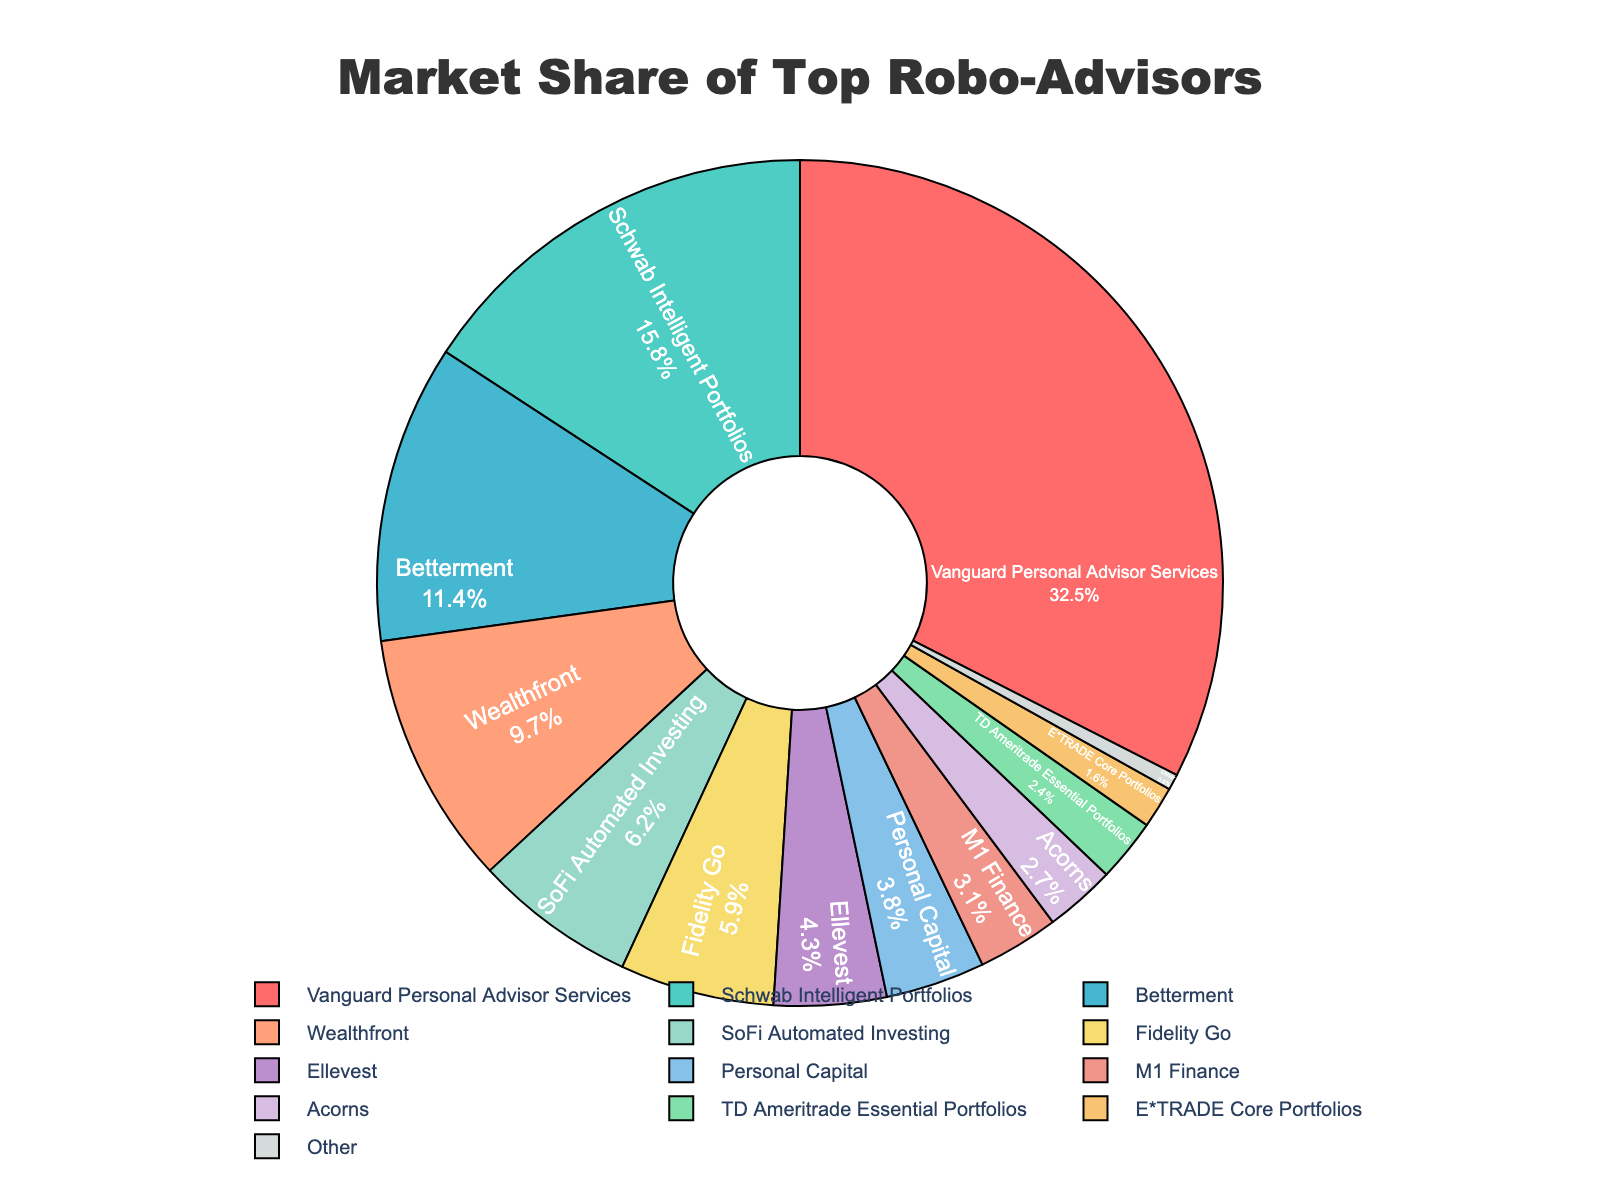Which company has the largest market share? The figure shows several companies and their corresponding market shares. The largest segment in the pie chart is colored and labeled with Vanguard Personal Advisor Services at 32.5%.
Answer: Vanguard Personal Advisor Services What's the combined market share of Schwab Intelligent Portfolios and Betterment? Schwab Intelligent Portfolios has a market share of 15.8%, and Betterment has 11.4%. Adding these two values gives 15.8 + 11.4 = 27.2%.
Answer: 27.2% Which company has a market share less than 5% but more than 3%? By looking at the segments, Fidelity Go (5.9%) is slightly more than 5%, but three companies lie between 3% and 5%: Ellevest (4.3%), Personal Capital (3.8%), and M1 Finance (3.1%).
Answer: Ellevest, Personal Capital, M1 Finance What is the market share difference between Wealthfront and SoFi Automated Investing? Wealthfront has a market share of 9.7% and SoFi Automated Investing has 6.2%. The difference is calculated as 9.7 - 6.2 = 3.5%.
Answer: 3.5% Which company has the smallest market share and what is it? The figure indicates multiple companies, but the smallest segment is denoted as "Other" with a market share of 0.6%.
Answer: Other, 0.6% How does the market share of Acorns compare to that of TD Ameritrade Essential Portfolios? The market share for Acorns is 2.7%, while TD Ameritrade Essential Portfolios have a market share of 2.4%. Acorns has a slightly higher market share than TD Ameritrade Essential Portfolios.
Answer: Acorns is higher What is the total market share of the companies that have a market share less than 10%? The companies with less than 10% market share are Betterment (11.4% is excluded), Wealthfront (9.7%), SoFi Automated Investing (6.2%), Fidelity Go (5.9%), Ellevest (4.3%), Personal Capital (3.8%), M1 Finance (3.1%), Acorns (2.7%), TD Ameritrade Essential Portfolios (2.4%), E*TRADE Core Portfolios (1.6%), and Other (0.6%). Summing these up: 9.7 + 6.2 + 5.9 + 4.3 + 3.8 + 3.1 + 2.7 + 2.4 + 1.6 + 0.6 = 40.3%.
Answer: 40.3% What percentage of the market is captured by companies that are not in the top 4 by market share? The top 4 companies by market share are Vanguard Personal Advisor Services (32.5%), Schwab Intelligent Portfolios (15.8%), Betterment (11.4%), and Wealthfront (9.7%). Adding these gives 32.5 + 15.8 + 11.4 + 9.7 = 69.4%. The rest of the companies capture 100% - 69.4% = 30.6% of the market.
Answer: 30.6% Which segment is represented by the pink color and what is its market share? In the pie chart, colors are assigned to segments. The pink segment corresponds to the first segment which is Vanguard Personal Advisor Services with a market share of 32.5%.
Answer: Vanguard Personal Advisor Services, 32.5% Which two companies have market shares closest to each other? Upon examining the market share values, Fidelity Go (5.9%) and SoFi Automated Investing (6.2%) are very close to each other, with a difference of just 0.3%.
Answer: Fidelity Go and SoFi Automated Investing 